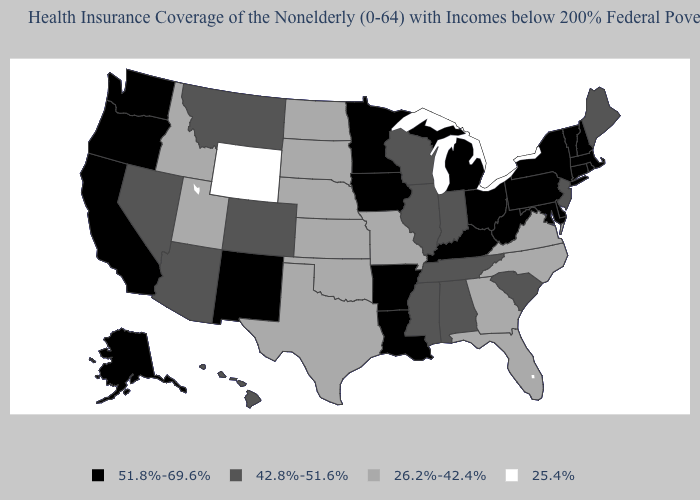What is the value of Wisconsin?
Quick response, please. 42.8%-51.6%. What is the lowest value in the USA?
Give a very brief answer. 25.4%. Is the legend a continuous bar?
Be succinct. No. What is the value of Mississippi?
Be succinct. 42.8%-51.6%. Is the legend a continuous bar?
Be succinct. No. What is the lowest value in the South?
Quick response, please. 26.2%-42.4%. What is the value of Michigan?
Keep it brief. 51.8%-69.6%. Is the legend a continuous bar?
Write a very short answer. No. What is the lowest value in states that border Oregon?
Give a very brief answer. 26.2%-42.4%. Does the first symbol in the legend represent the smallest category?
Give a very brief answer. No. What is the highest value in the South ?
Be succinct. 51.8%-69.6%. Among the states that border Idaho , which have the highest value?
Write a very short answer. Oregon, Washington. What is the value of Florida?
Short answer required. 26.2%-42.4%. Name the states that have a value in the range 51.8%-69.6%?
Concise answer only. Alaska, Arkansas, California, Connecticut, Delaware, Iowa, Kentucky, Louisiana, Maryland, Massachusetts, Michigan, Minnesota, New Hampshire, New Mexico, New York, Ohio, Oregon, Pennsylvania, Rhode Island, Vermont, Washington, West Virginia. Name the states that have a value in the range 26.2%-42.4%?
Concise answer only. Florida, Georgia, Idaho, Kansas, Missouri, Nebraska, North Carolina, North Dakota, Oklahoma, South Dakota, Texas, Utah, Virginia. 